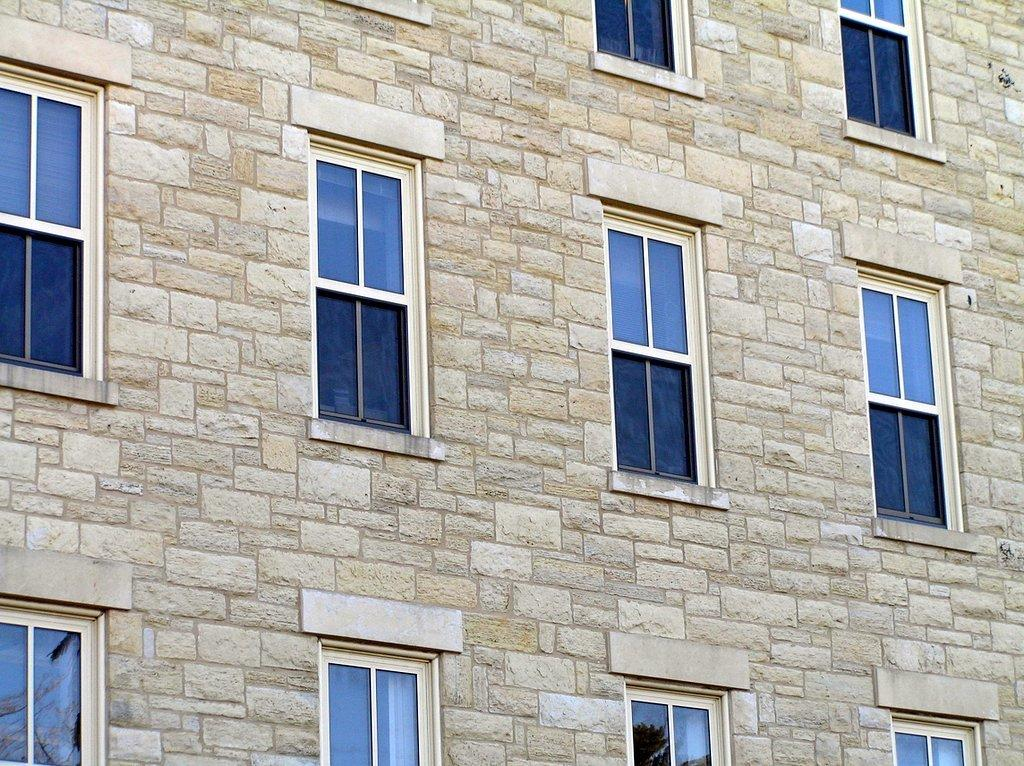What can be seen in the image? There is a wall in the image. What feature of the wall is mentioned in the facts? The wall has multiple windows. What material are the windows made of? The windows are made of glass. What type of game is being played in the image? There is no game being played in the image; it only features a wall with multiple windows made of glass. 